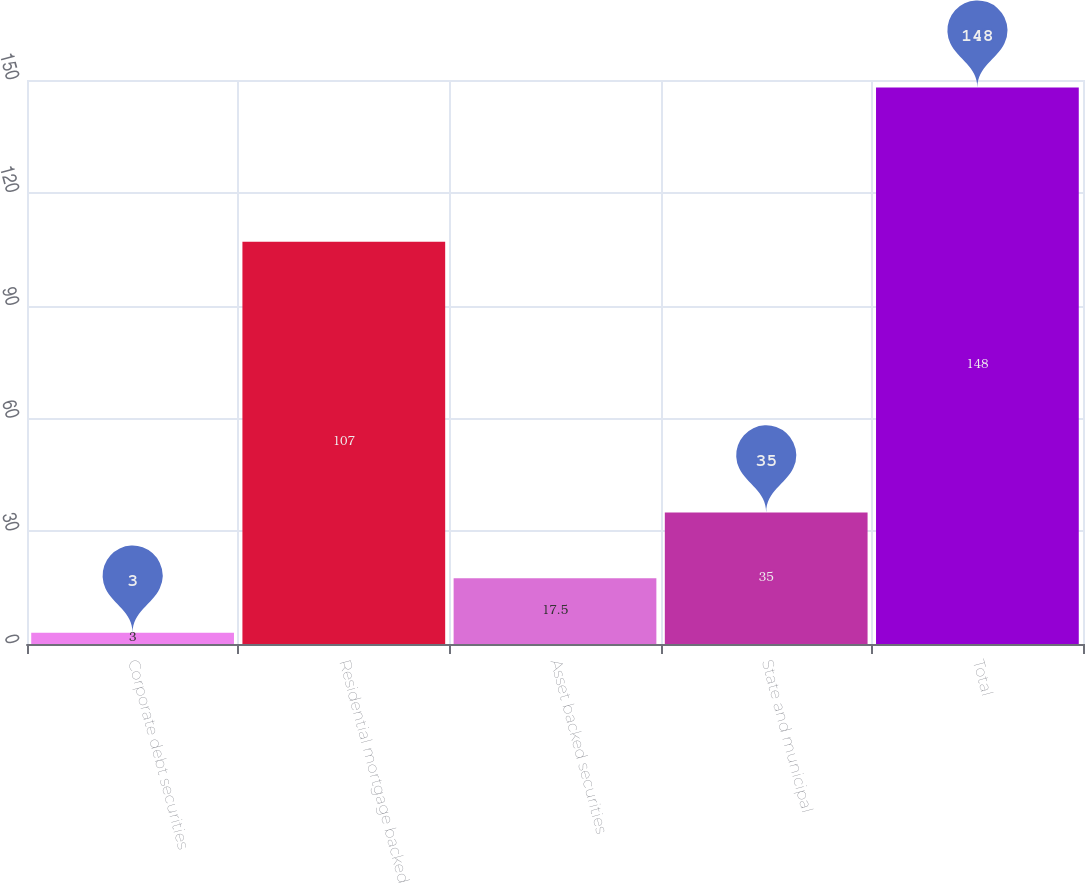Convert chart. <chart><loc_0><loc_0><loc_500><loc_500><bar_chart><fcel>Corporate debt securities<fcel>Residential mortgage backed<fcel>Asset backed securities<fcel>State and municipal<fcel>Total<nl><fcel>3<fcel>107<fcel>17.5<fcel>35<fcel>148<nl></chart> 